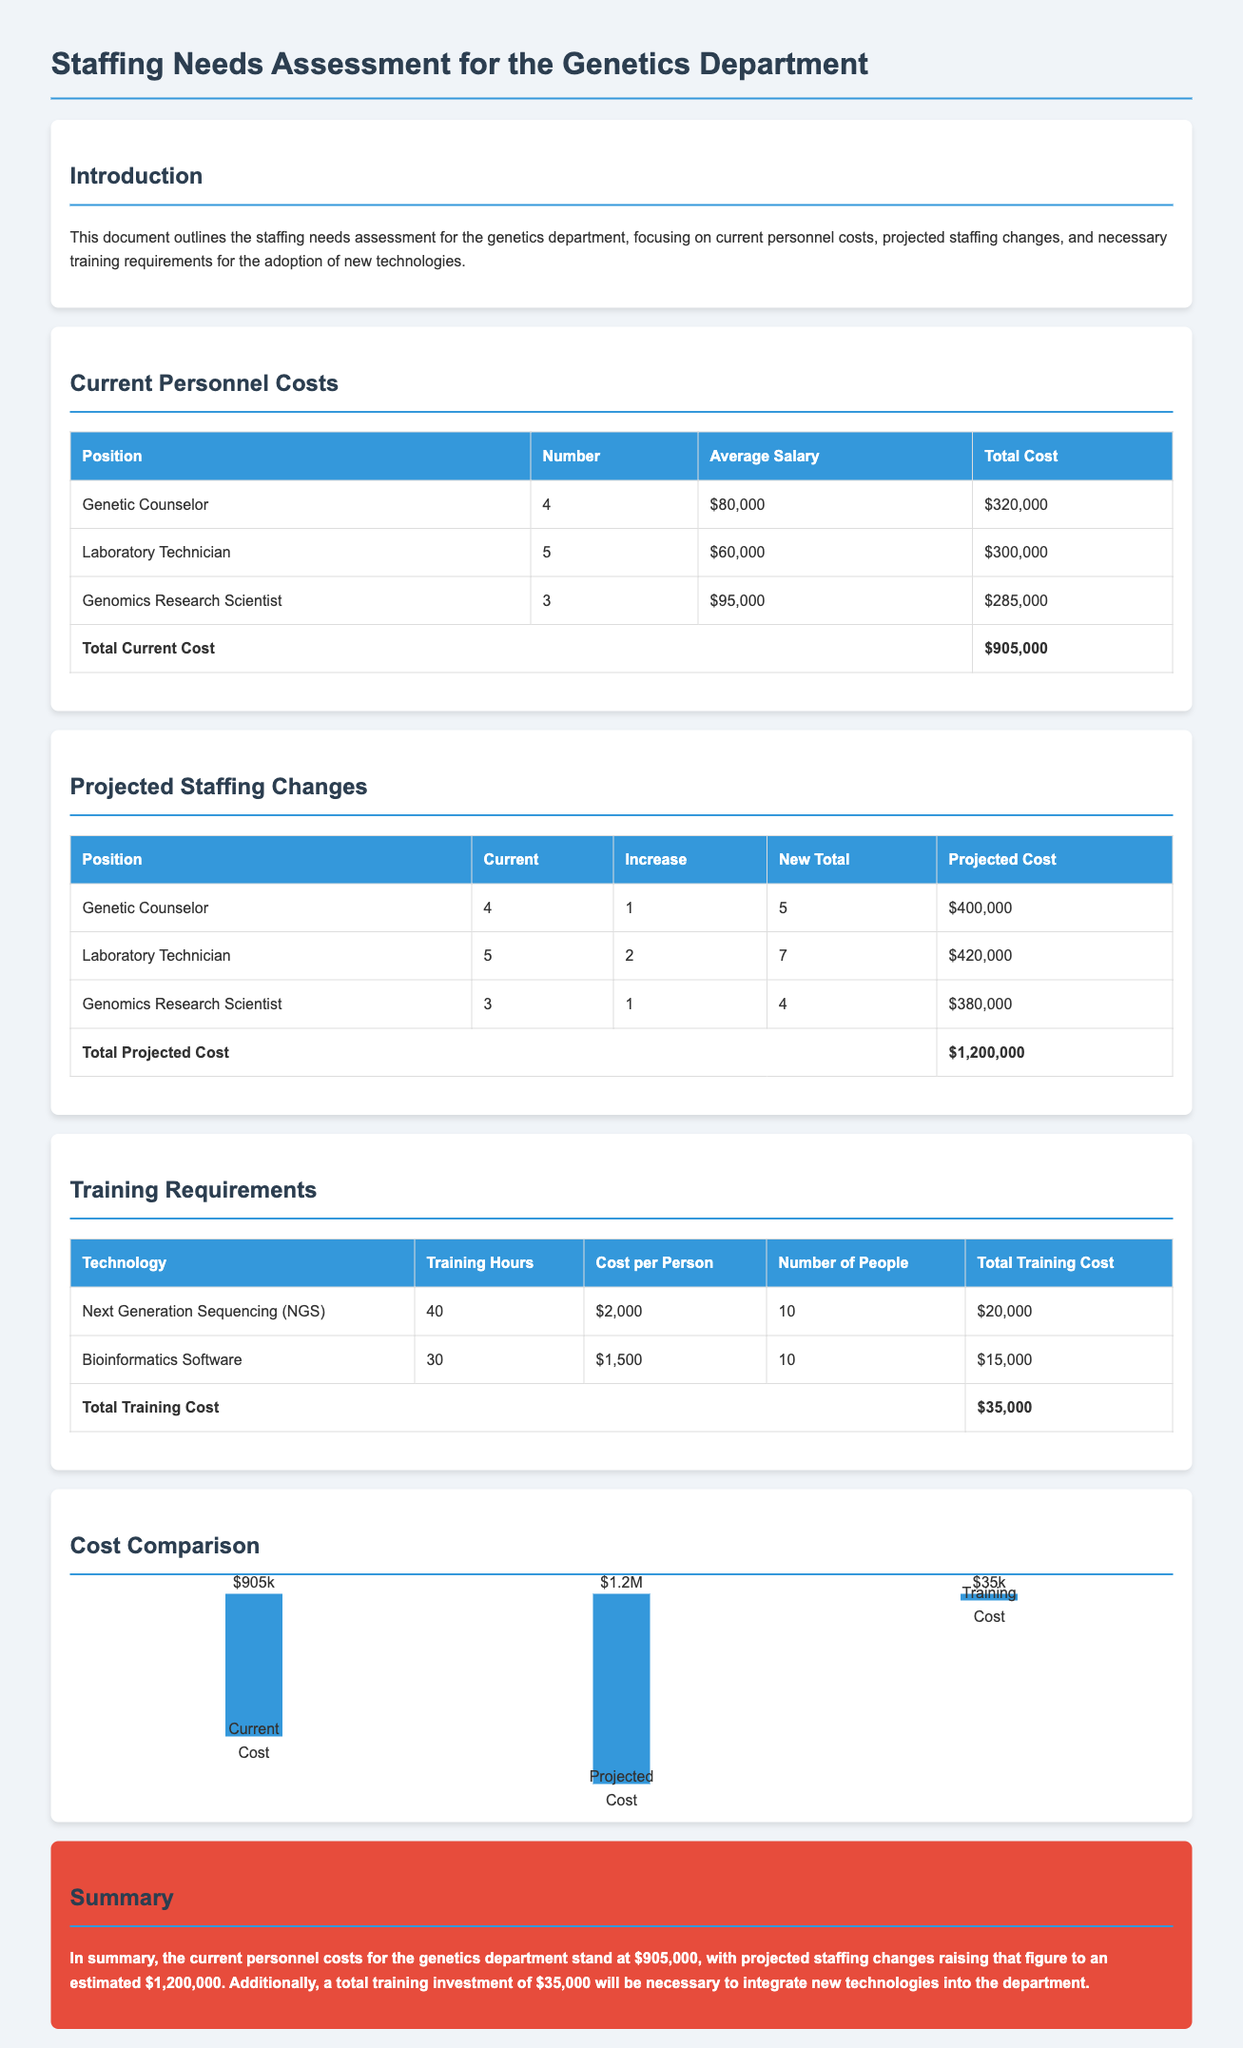What is the total current cost for the genetics department? The total current cost is displayed in the document's table under "Current Personnel Costs," which sums up to $905,000.
Answer: $905,000 How many Genetic Counselors are currently employed? The document lists the number of each position in the "Current Personnel Costs" table, indicating there are currently 4 Genetic Counselors.
Answer: 4 What is the projected cost after staffing changes? The projected cost is presented in the "Projected Staffing Changes" table, which totals $1,200,000.
Answer: $1,200,000 How many hours of training are required for Next Generation Sequencing? The training requirements table specifies that 40 training hours are needed for Next Generation Sequencing (NGS).
Answer: 40 What is the total training investment? The document summarizes the total training cost at the end of the "Training Requirements" section, which is $35,000.
Answer: $35,000 Which position is projected to have the highest staffing increase? The "Projected Staffing Changes" table shows that the Laboratory Technician position has the highest increase, with 2 additional staff members.
Answer: Laboratory Technician What is the average salary for a Genomics Research Scientist? The average salary for a Genomics Research Scientist is found in the "Current Personnel Costs" table, listed as $95,000.
Answer: $95,000 What technology requires the most training hours? Among the listed technologies, Next Generation Sequencing (NGS) requires the most training hours at 40.
Answer: Next Generation Sequencing (NGS) What color is used for table headers in the document? The table headers are styled in blue, as indicated in the document's styling section for the header.
Answer: Blue 